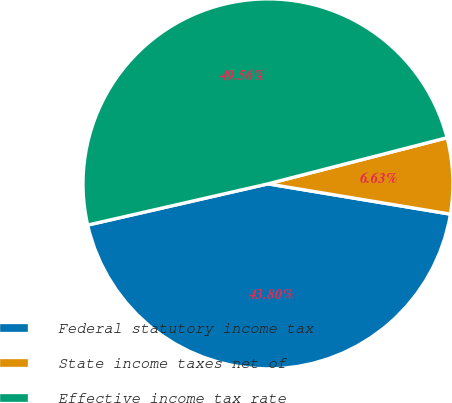<chart> <loc_0><loc_0><loc_500><loc_500><pie_chart><fcel>Federal statutory income tax<fcel>State income taxes net of<fcel>Effective income tax rate<nl><fcel>43.8%<fcel>6.63%<fcel>49.56%<nl></chart> 